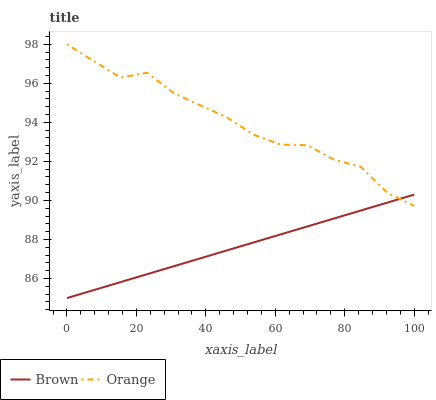Does Brown have the minimum area under the curve?
Answer yes or no. Yes. Does Orange have the maximum area under the curve?
Answer yes or no. Yes. Does Brown have the maximum area under the curve?
Answer yes or no. No. Is Brown the smoothest?
Answer yes or no. Yes. Is Orange the roughest?
Answer yes or no. Yes. Is Brown the roughest?
Answer yes or no. No. Does Brown have the lowest value?
Answer yes or no. Yes. Does Orange have the highest value?
Answer yes or no. Yes. Does Brown have the highest value?
Answer yes or no. No. Does Brown intersect Orange?
Answer yes or no. Yes. Is Brown less than Orange?
Answer yes or no. No. Is Brown greater than Orange?
Answer yes or no. No. 